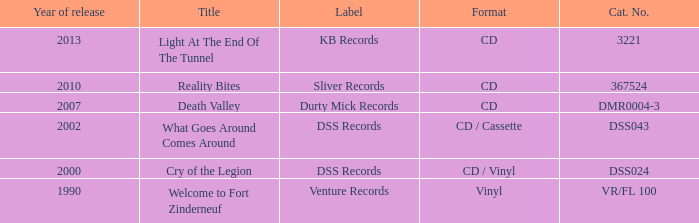What is the full year of launch for the title "what goes around comes around"? 1.0. 